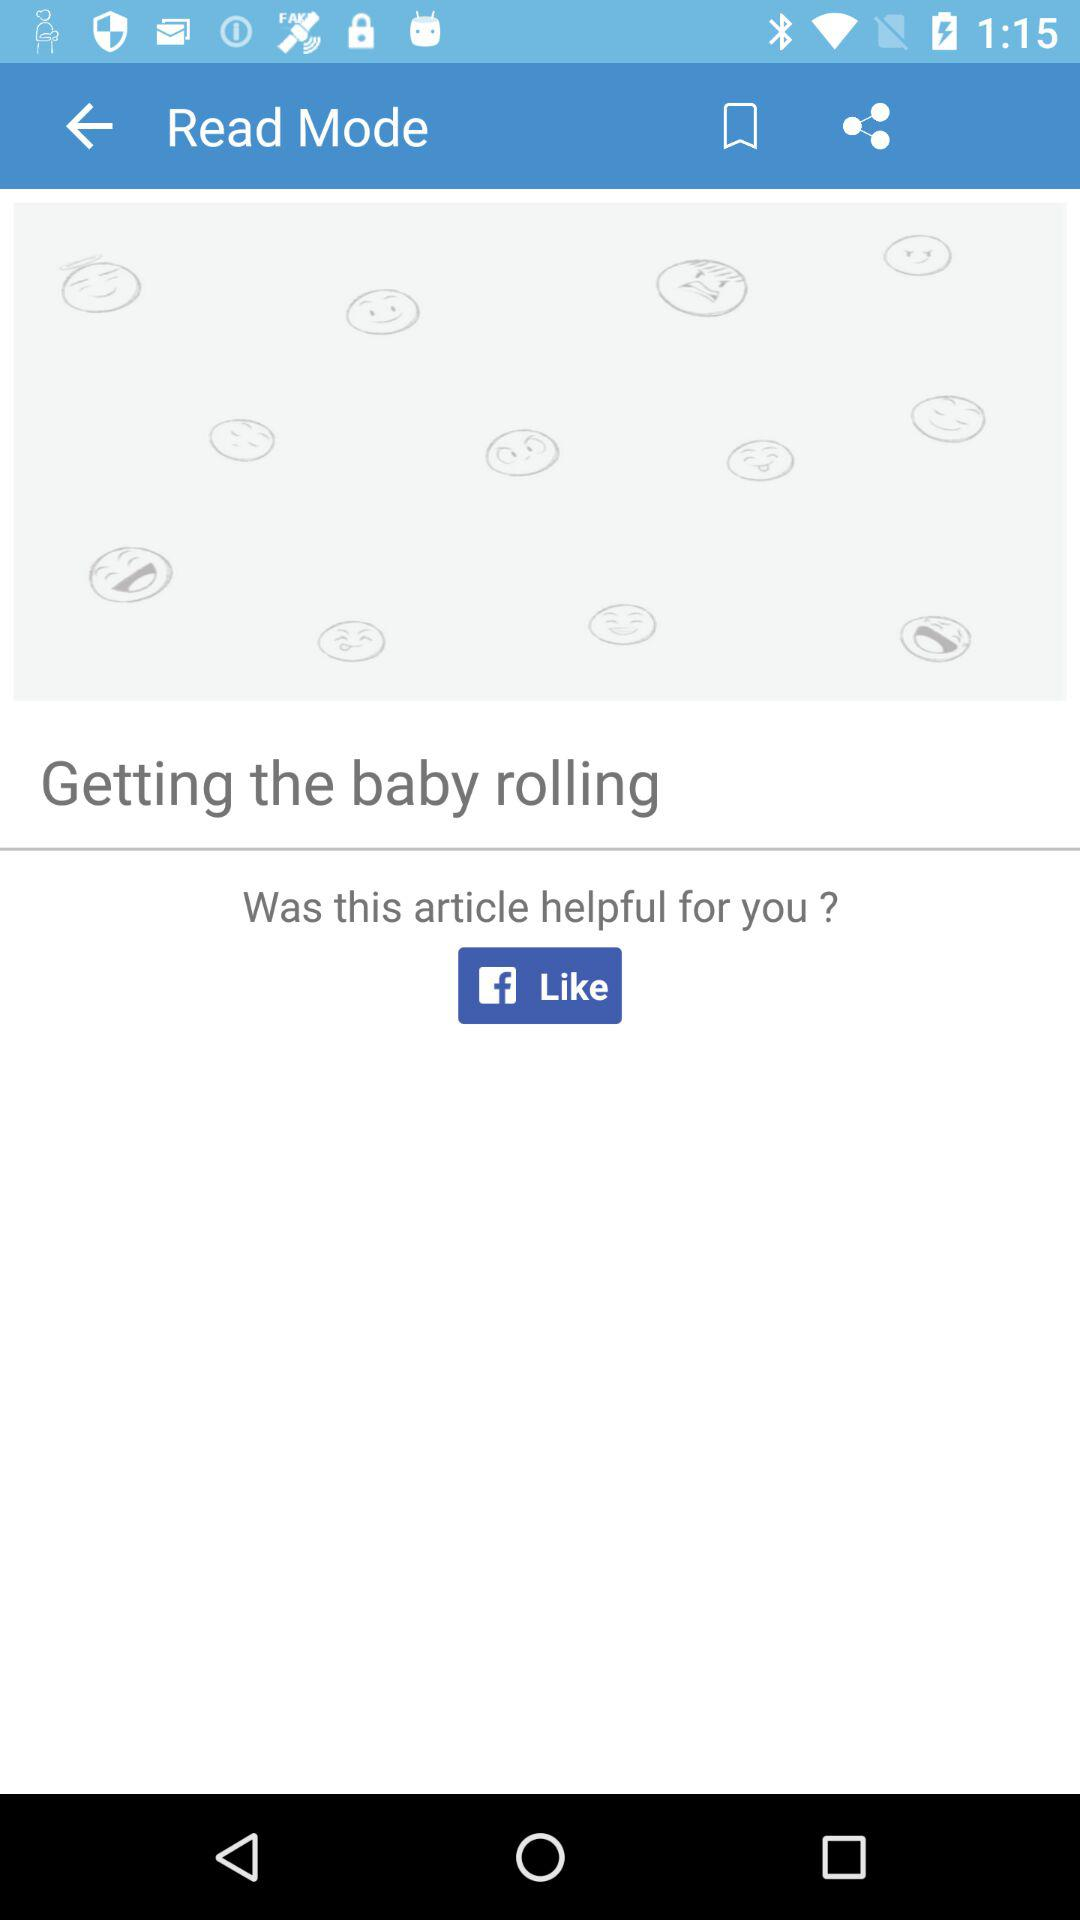How many smiley faces have a closed eye?
Answer the question using a single word or phrase. 8 